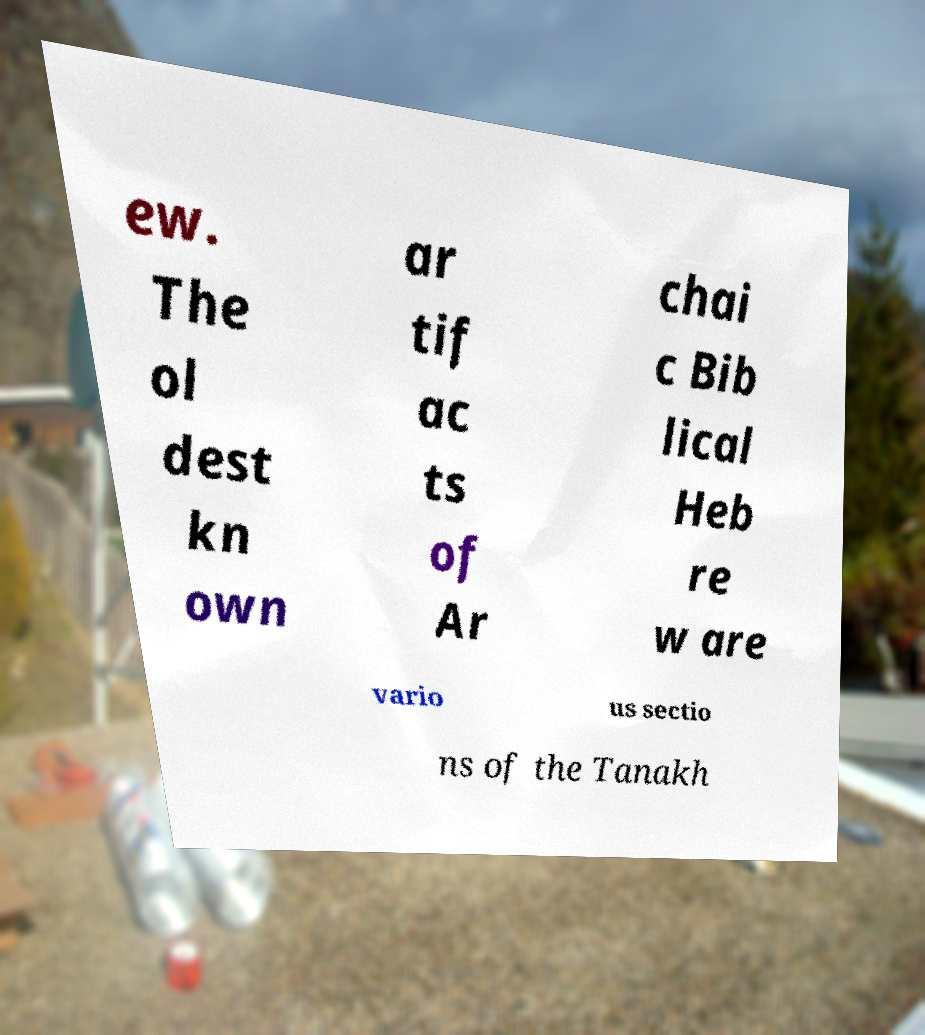Please read and relay the text visible in this image. What does it say? ew. The ol dest kn own ar tif ac ts of Ar chai c Bib lical Heb re w are vario us sectio ns of the Tanakh 